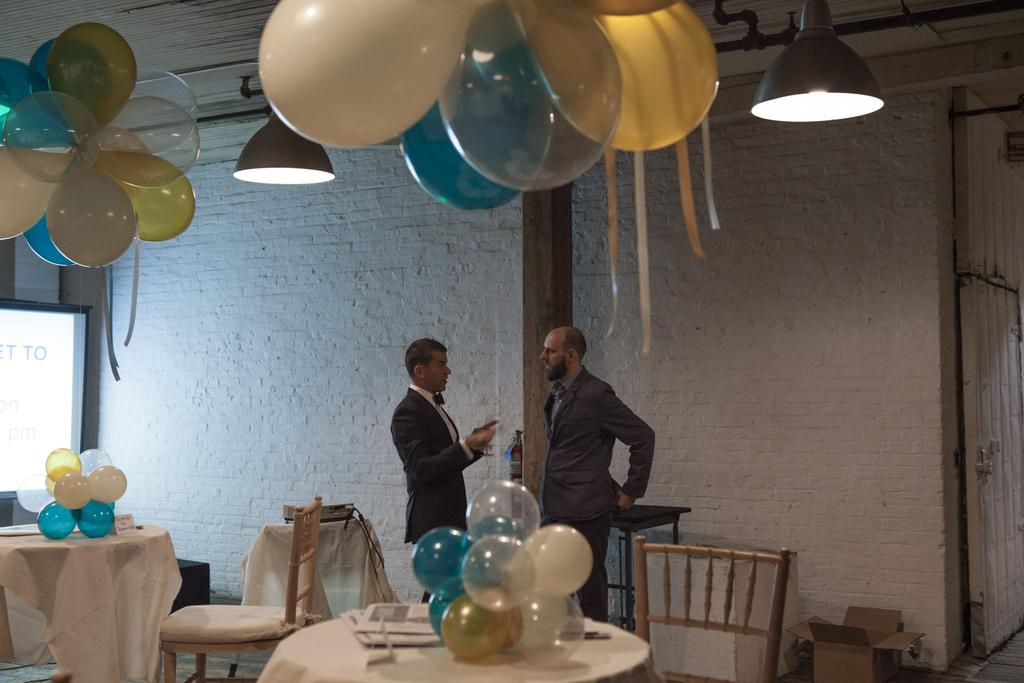How many people are present in the image? There are two people in the image. What are the people doing in the image? The people are standing. What objects can be seen on a table in the image? There are balloons on a table in the image. What type of alarm is ringing in the image? There is no alarm present in the image. What can be seen on a desk in the image? There is no desk present in the image. 